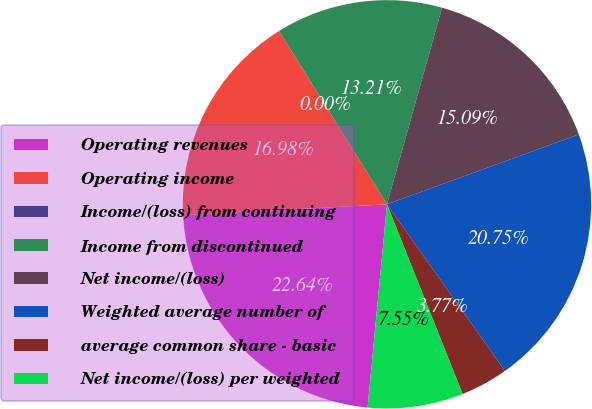<chart> <loc_0><loc_0><loc_500><loc_500><pie_chart><fcel>Operating revenues<fcel>Operating income<fcel>Income/(loss) from continuing<fcel>Income from discontinued<fcel>Net income/(loss)<fcel>Weighted average number of<fcel>average common share - basic<fcel>Net income/(loss) per weighted<nl><fcel>22.64%<fcel>16.98%<fcel>0.0%<fcel>13.21%<fcel>15.09%<fcel>20.75%<fcel>3.77%<fcel>7.55%<nl></chart> 